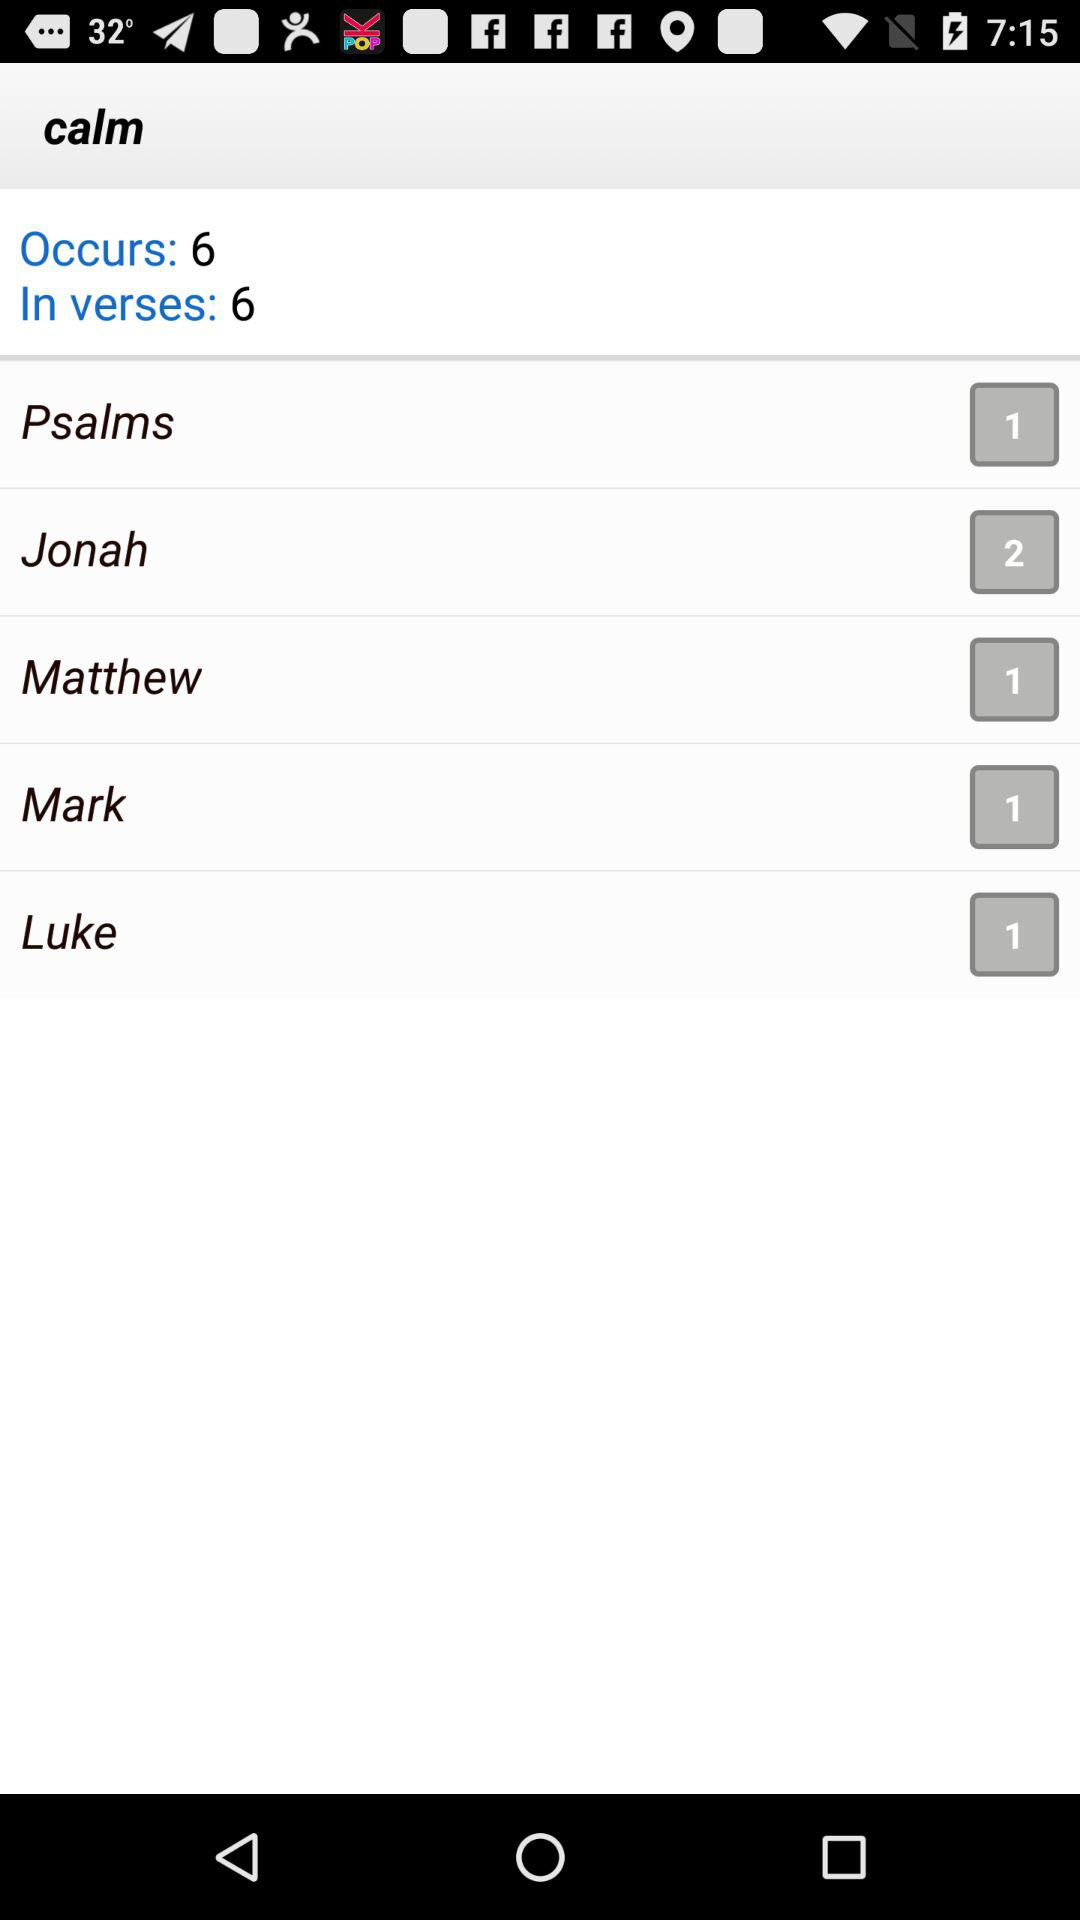What is total number of occurs? The total number of occurrs is 6. 